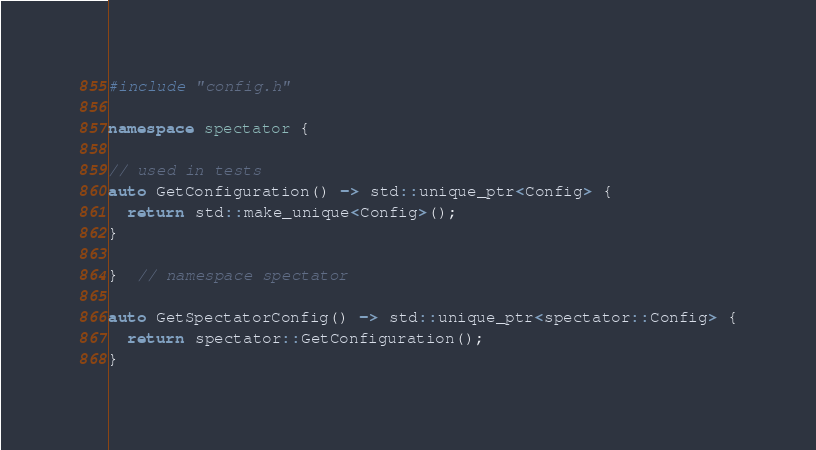Convert code to text. <code><loc_0><loc_0><loc_500><loc_500><_C++_>#include "config.h"

namespace spectator {

// used in tests
auto GetConfiguration() -> std::unique_ptr<Config> {
  return std::make_unique<Config>();
}

}  // namespace spectator

auto GetSpectatorConfig() -> std::unique_ptr<spectator::Config> {
  return spectator::GetConfiguration();
}
</code> 